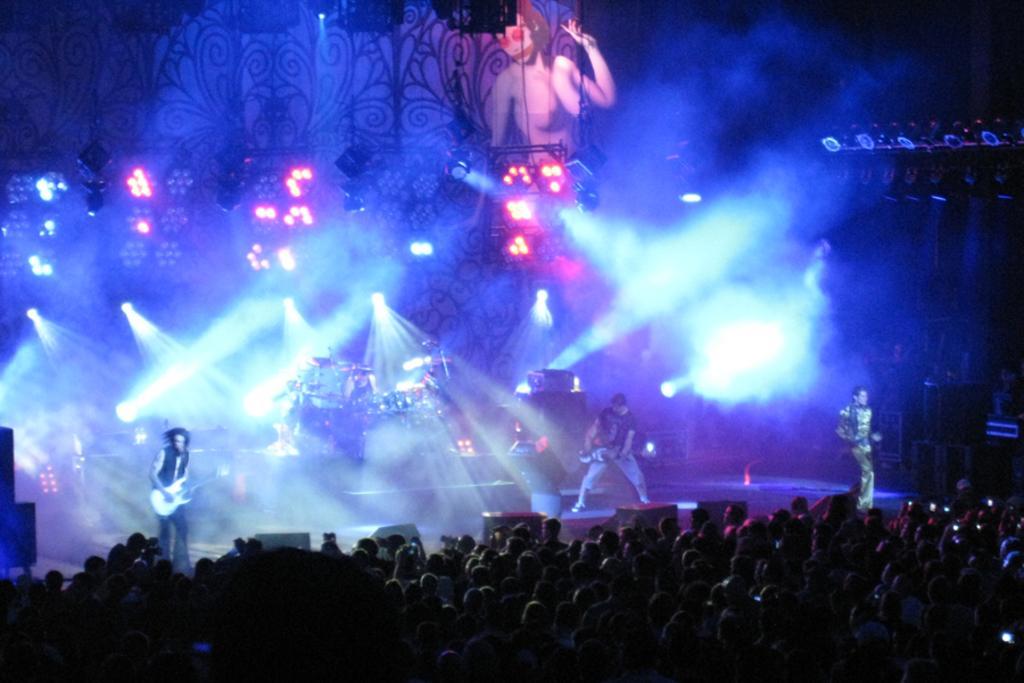In one or two sentences, can you explain what this image depicts? In this picture we can see people standing and playing musical instruments. On the right side of the picture we can see a man standing. At the bottom portion of the picture we can see people and it is dark. In the background we can see musical instruments, lights and a board. We can see objects on the platform. 